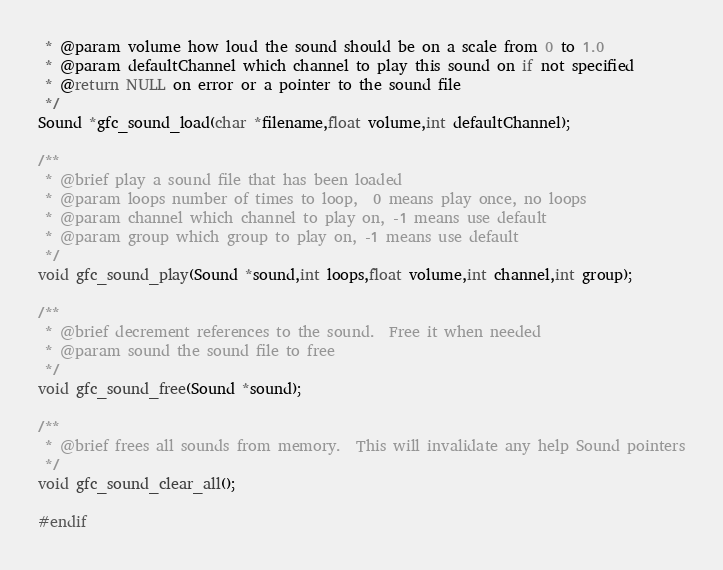Convert code to text. <code><loc_0><loc_0><loc_500><loc_500><_C_> * @param volume how loud the sound should be on a scale from 0 to 1.0
 * @param defaultChannel which channel to play this sound on if not specified
 * @return NULL on error or a pointer to the sound file
 */
Sound *gfc_sound_load(char *filename,float volume,int defaultChannel);

/**
 * @brief play a sound file that has been loaded
 * @param loops number of times to loop,  0 means play once, no loops
 * @param channel which channel to play on, -1 means use default
 * @param group which group to play on, -1 means use default
 */
void gfc_sound_play(Sound *sound,int loops,float volume,int channel,int group);

/**
 * @brief decrement references to the sound.  Free it when needed
 * @param sound the sound file to free
 */
void gfc_sound_free(Sound *sound);

/**
 * @brief frees all sounds from memory.  This will invalidate any help Sound pointers
 */
void gfc_sound_clear_all();

#endif
</code> 